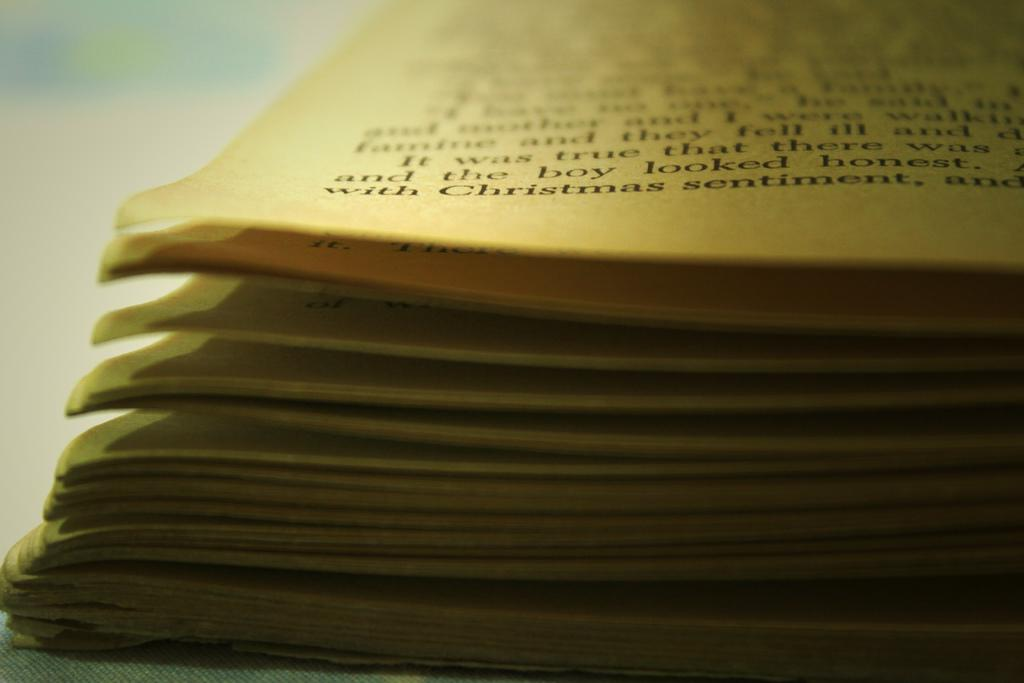Provide a one-sentence caption for the provided image. A book lays open with the word Christmas sentiment visible. 